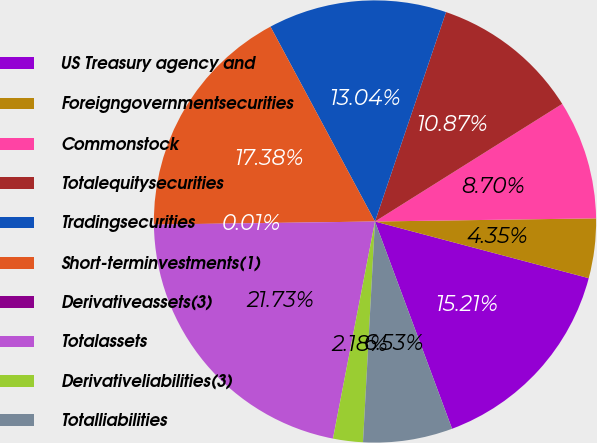Convert chart to OTSL. <chart><loc_0><loc_0><loc_500><loc_500><pie_chart><fcel>US Treasury agency and<fcel>Foreigngovernmentsecurities<fcel>Commonstock<fcel>Totalequitysecurities<fcel>Tradingsecurities<fcel>Short-terminvestments(1)<fcel>Derivativeassets(3)<fcel>Totalassets<fcel>Derivativeliabilities(3)<fcel>Totalliabilities<nl><fcel>15.21%<fcel>4.35%<fcel>8.7%<fcel>10.87%<fcel>13.04%<fcel>17.38%<fcel>0.01%<fcel>21.73%<fcel>2.18%<fcel>6.53%<nl></chart> 